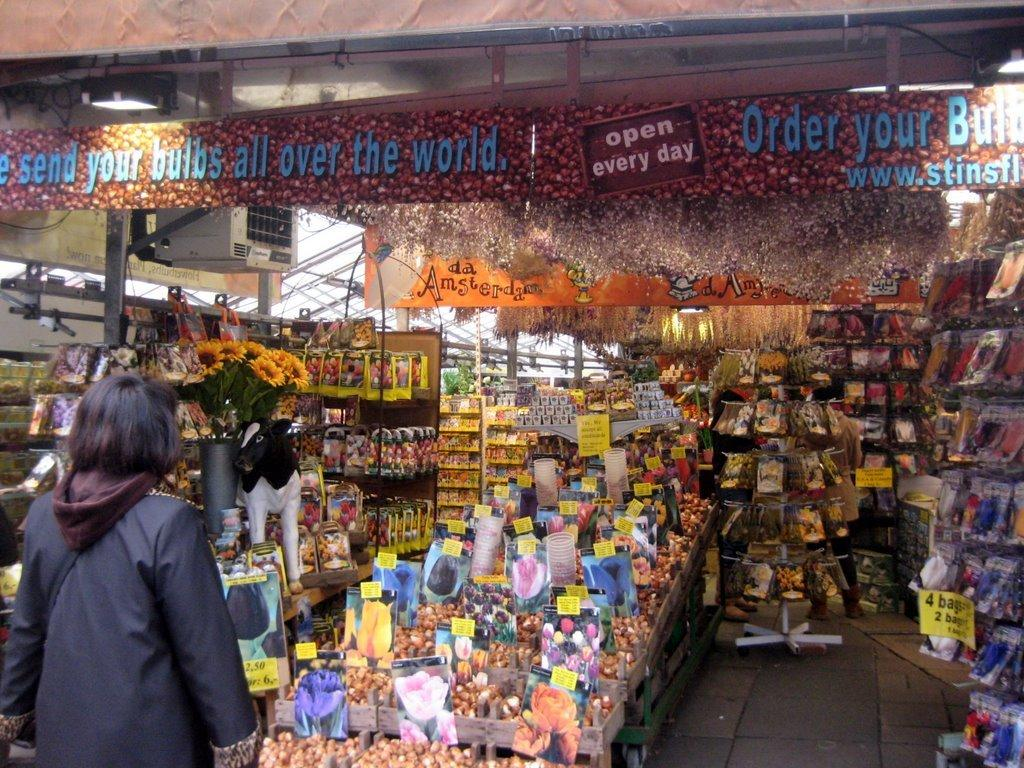<image>
Write a terse but informative summary of the picture. A marketplace with a sign saying open every day. 